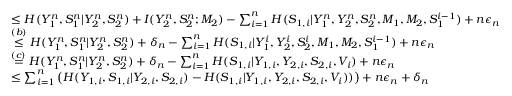<formula> <loc_0><loc_0><loc_500><loc_500>\begin{array} { r l } & { \leq H ( Y _ { 1 } ^ { n } , S _ { 1 } ^ { n } | Y _ { 2 } ^ { n } , S _ { 2 } ^ { n } ) + I ( Y _ { 2 } ^ { n } , S _ { 2 } ^ { n } ; M _ { 2 } ) - \sum _ { i = 1 } ^ { n } H ( S _ { 1 , i } | Y _ { 1 } ^ { n } , Y _ { 2 } ^ { n } , S _ { 2 } ^ { n } , M _ { 1 } , M _ { 2 } , S _ { 1 } ^ { i - 1 } ) + n \epsilon _ { n } } \\ & { \overset { ( b ) } { \leq } H ( Y _ { 1 } ^ { n } , S _ { 1 } ^ { n } | Y _ { 2 } ^ { n } , S _ { 2 } ^ { n } ) + \delta _ { n } - \sum _ { i = 1 } ^ { n } H ( S _ { 1 , i } | Y _ { 1 } ^ { i } , Y _ { 2 } ^ { i } , S _ { 2 } ^ { i } , M _ { 1 } , M _ { 2 } , S _ { 1 } ^ { i - 1 } ) + n \epsilon _ { n } } \\ & { \overset { ( c ) } { = } H ( Y _ { 1 } ^ { n } , S _ { 1 } ^ { n } | Y _ { 2 } ^ { n } , S _ { 2 } ^ { n } ) + \delta _ { n } - \sum _ { i = 1 } ^ { n } H ( S _ { 1 , i } | Y _ { 1 , i } , Y _ { 2 , i } , S _ { 2 , i } , V _ { i } ) + n \epsilon _ { n } } \\ & { \leq \sum _ { i = 1 } ^ { n } \left ( H ( Y _ { 1 , i } , S _ { 1 , i } | Y _ { 2 , i } , S _ { 2 , i } ) - H ( S _ { 1 , i } | Y _ { 1 , i } , Y _ { 2 , i } , S _ { 2 , i } , V _ { i } ) ) \right ) + n \epsilon _ { n } + \delta _ { n } } \end{array}</formula> 